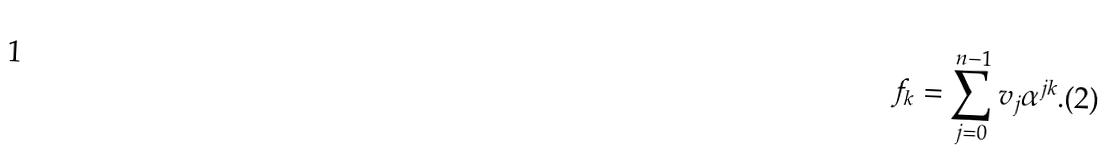Convert formula to latex. <formula><loc_0><loc_0><loc_500><loc_500>f _ { k } = \sum _ { j = 0 } ^ { n - 1 } v _ { j } \alpha ^ { j k } . ( 2 )</formula> 